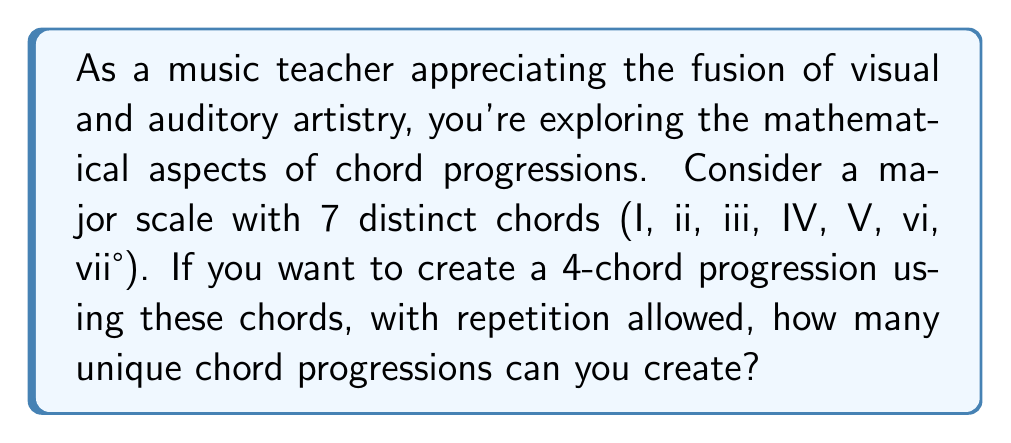Can you solve this math problem? To solve this problem, we need to use the multiplication principle of counting. Here's a step-by-step explanation:

1. We have 7 choices for each position in the 4-chord progression.
2. The choices are independent, meaning the selection of one chord does not affect the choices for the other positions.
3. Repetition is allowed, so we can use the same chord multiple times in the progression.
4. For each of the 4 positions in the progression, we have 7 choices.

Therefore, we can calculate the total number of possible chord progressions as follows:

$$ \text{Total progressions} = 7 \times 7 \times 7 \times 7 = 7^4 $$

This is because:
- For the first chord, we have 7 choices
- For the second chord, we again have 7 choices
- For the third chord, we again have 7 choices
- For the fourth chord, we again have 7 choices

Multiplying these together gives us the total number of possible combinations.

Calculating $7^4$:

$$ 7^4 = 7 \times 7 \times 7 \times 7 = 2,401 $$

This means there are 2,401 unique 4-chord progressions possible using the 7 chords of a major scale, with repetition allowed.
Answer: 2,401 unique chord progressions 